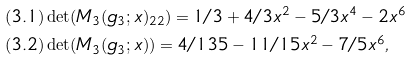<formula> <loc_0><loc_0><loc_500><loc_500>& ( 3 . 1 ) \det ( M _ { 3 } ( g _ { 3 } ; x ) _ { 2 2 } ) = 1 / 3 + 4 / 3 x ^ { 2 } - 5 / 3 x ^ { 4 } - 2 x ^ { 6 } \\ & ( 3 . 2 ) \det ( M _ { 3 } ( g _ { 3 } ; x ) ) = 4 / 1 3 5 - 1 1 / 1 5 x ^ { 2 } - 7 / 5 x ^ { 6 } ,</formula> 